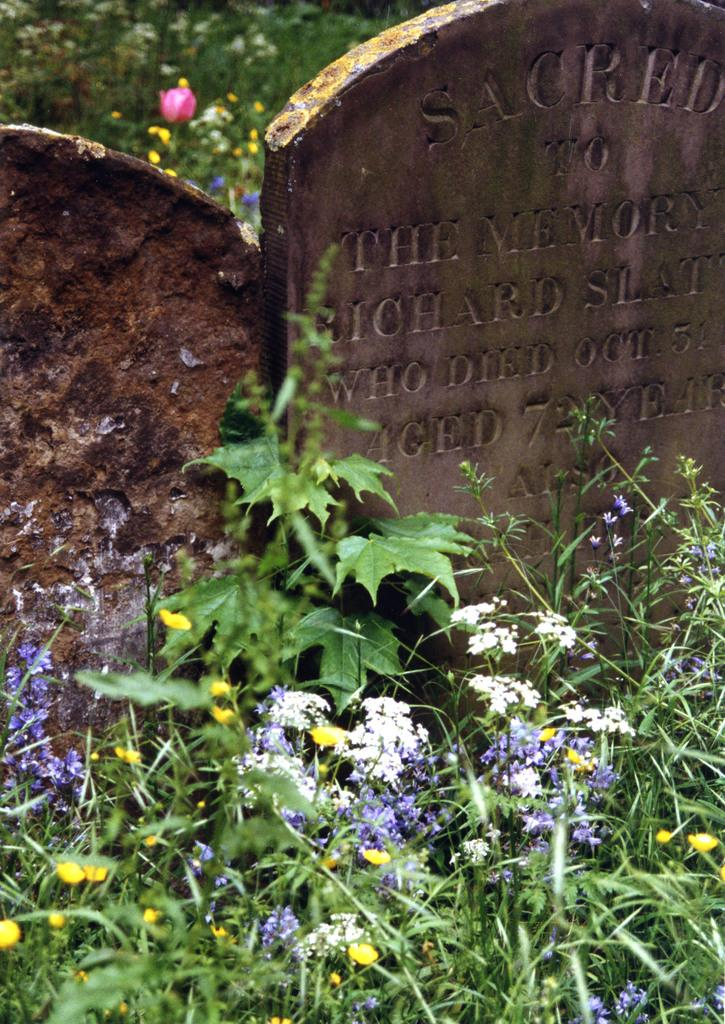What can be found on the graveyard stones in the image? There is text on the graveyard stones in the image. What type of vegetation is present in the image? There are plants, grass, and flowers in the image. Can you see a duck swimming in the image? There is no duck present in the image. Are there any bees buzzing around the flowers in the image? There is no mention of bees in the image, so it cannot be determined if they are present. 